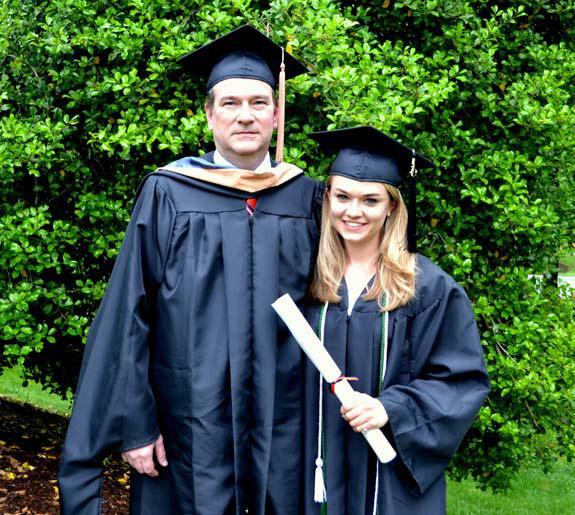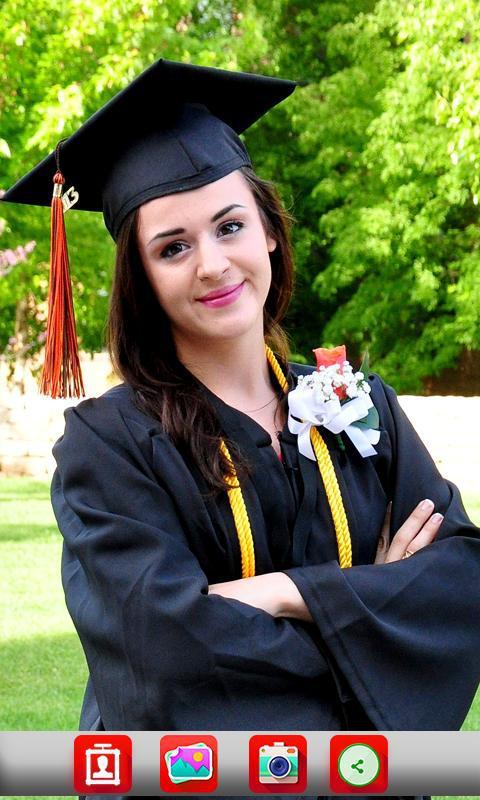The first image is the image on the left, the second image is the image on the right. Evaluate the accuracy of this statement regarding the images: "One picture has atleast 2 women in it.". Is it true? Answer yes or no. No. The first image is the image on the left, the second image is the image on the right. Analyze the images presented: Is the assertion "The left image contains exactly two people wearing graduation uniforms." valid? Answer yes or no. Yes. 